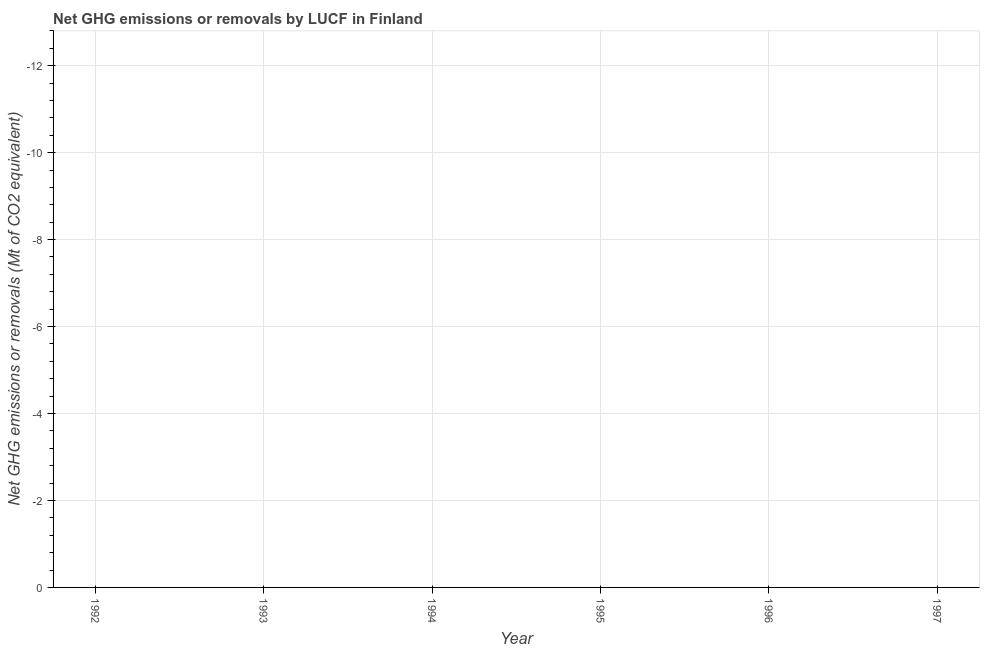Across all years, what is the minimum ghg net emissions or removals?
Your answer should be very brief. 0. What is the sum of the ghg net emissions or removals?
Your answer should be very brief. 0. What is the median ghg net emissions or removals?
Your response must be concise. 0. In how many years, is the ghg net emissions or removals greater than the average ghg net emissions or removals taken over all years?
Provide a succinct answer. 0. How many years are there in the graph?
Your answer should be compact. 6. Does the graph contain any zero values?
Make the answer very short. Yes. Does the graph contain grids?
Ensure brevity in your answer.  Yes. What is the title of the graph?
Provide a short and direct response. Net GHG emissions or removals by LUCF in Finland. What is the label or title of the Y-axis?
Give a very brief answer. Net GHG emissions or removals (Mt of CO2 equivalent). What is the Net GHG emissions or removals (Mt of CO2 equivalent) in 1994?
Give a very brief answer. 0. What is the Net GHG emissions or removals (Mt of CO2 equivalent) in 1997?
Offer a terse response. 0. 